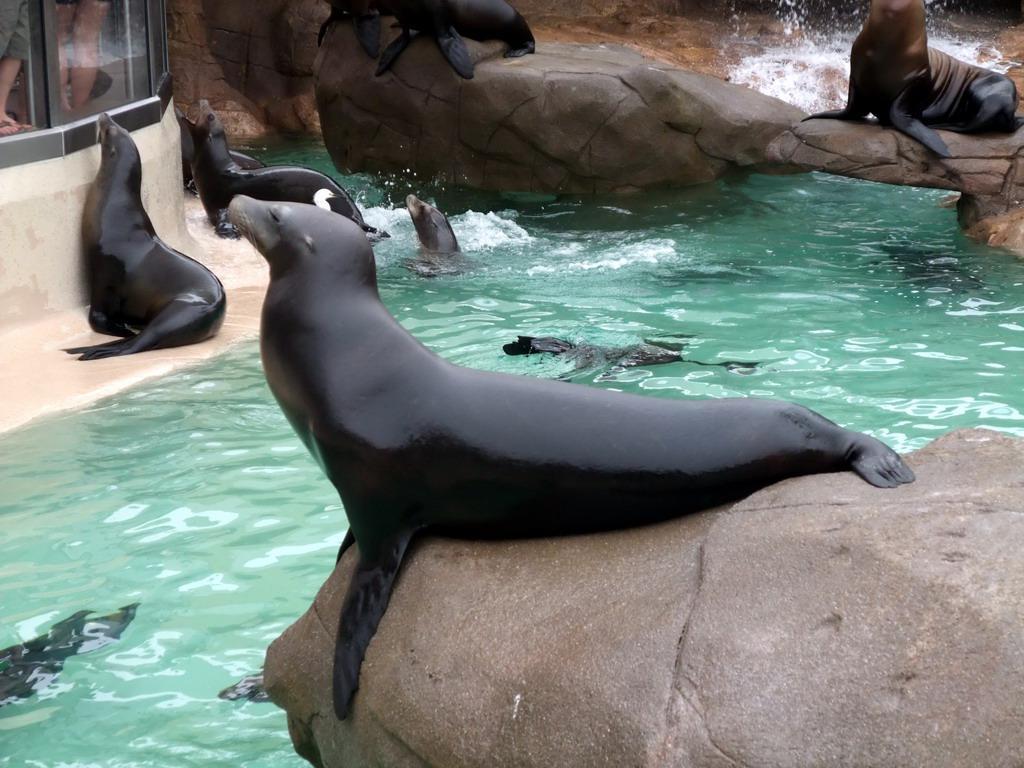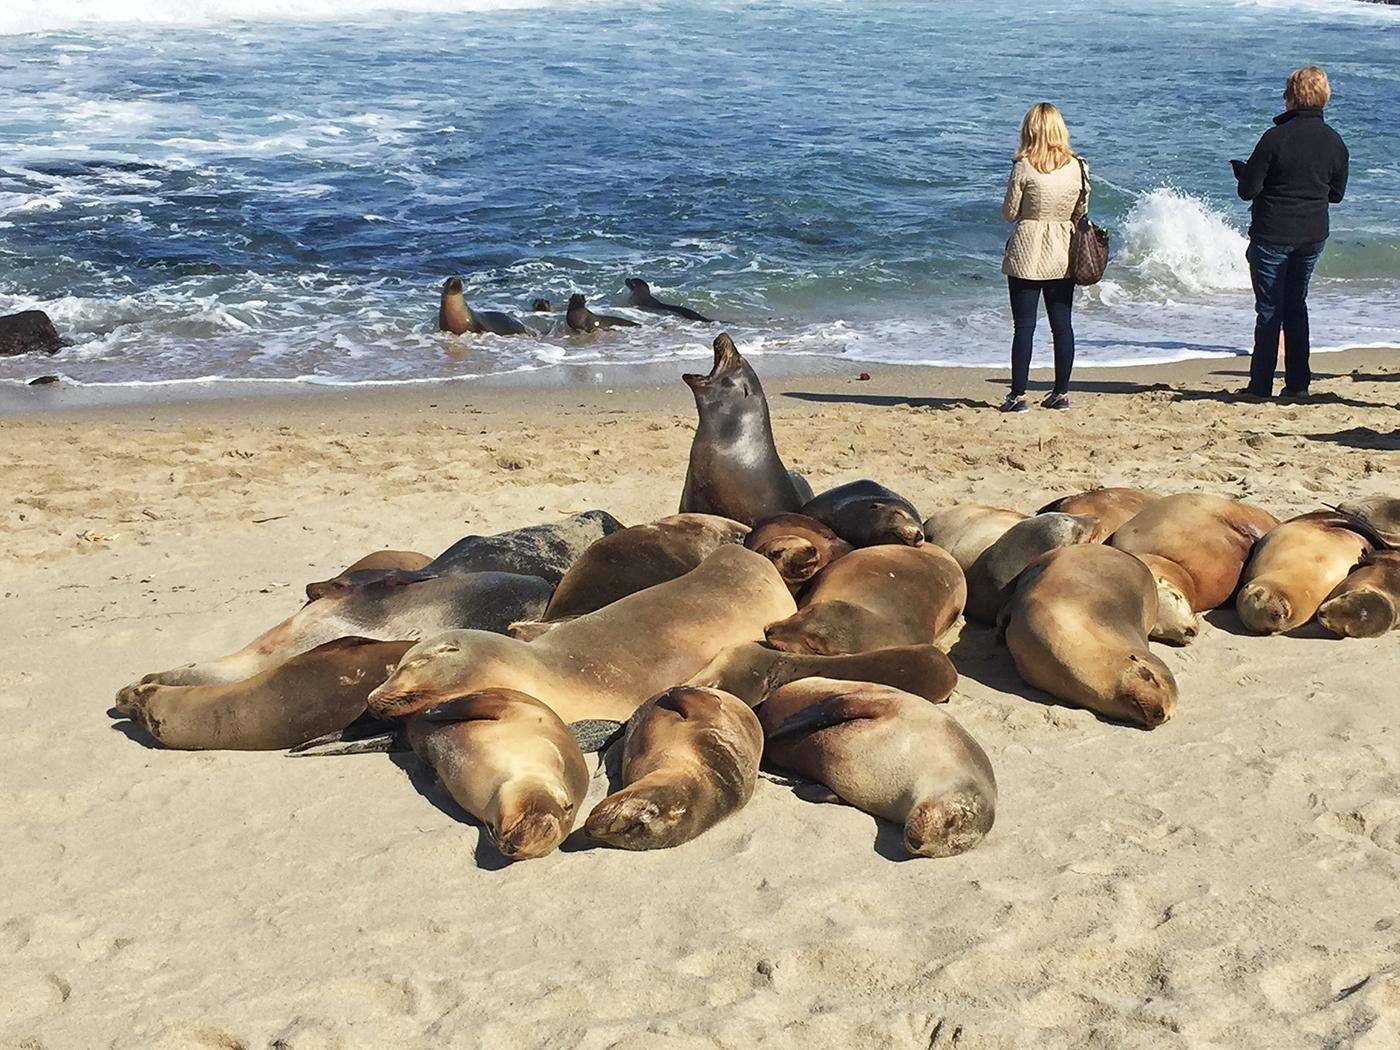The first image is the image on the left, the second image is the image on the right. For the images shown, is this caption "An image shows multiple seals lying on a plank-look manmade structure." true? Answer yes or no. No. The first image is the image on the left, the second image is the image on the right. Evaluate the accuracy of this statement regarding the images: "A seal is sitting on a large, elevated rock.". Is it true? Answer yes or no. Yes. 